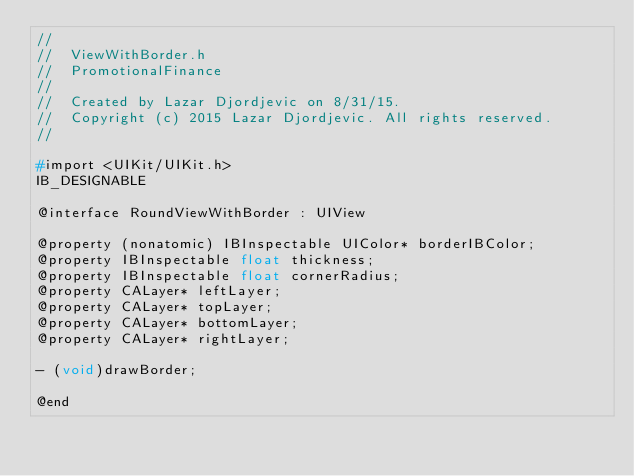Convert code to text. <code><loc_0><loc_0><loc_500><loc_500><_C_>//
//  ViewWithBorder.h
//  PromotionalFinance
//
//  Created by Lazar Djordjevic on 8/31/15.
//  Copyright (c) 2015 Lazar Djordjevic. All rights reserved.
//

#import <UIKit/UIKit.h>
IB_DESIGNABLE

@interface RoundViewWithBorder : UIView

@property (nonatomic) IBInspectable UIColor* borderIBColor;
@property IBInspectable float thickness;
@property IBInspectable float cornerRadius;
@property CALayer* leftLayer;
@property CALayer* topLayer;
@property CALayer* bottomLayer;
@property CALayer* rightLayer;

- (void)drawBorder;

@end

</code> 